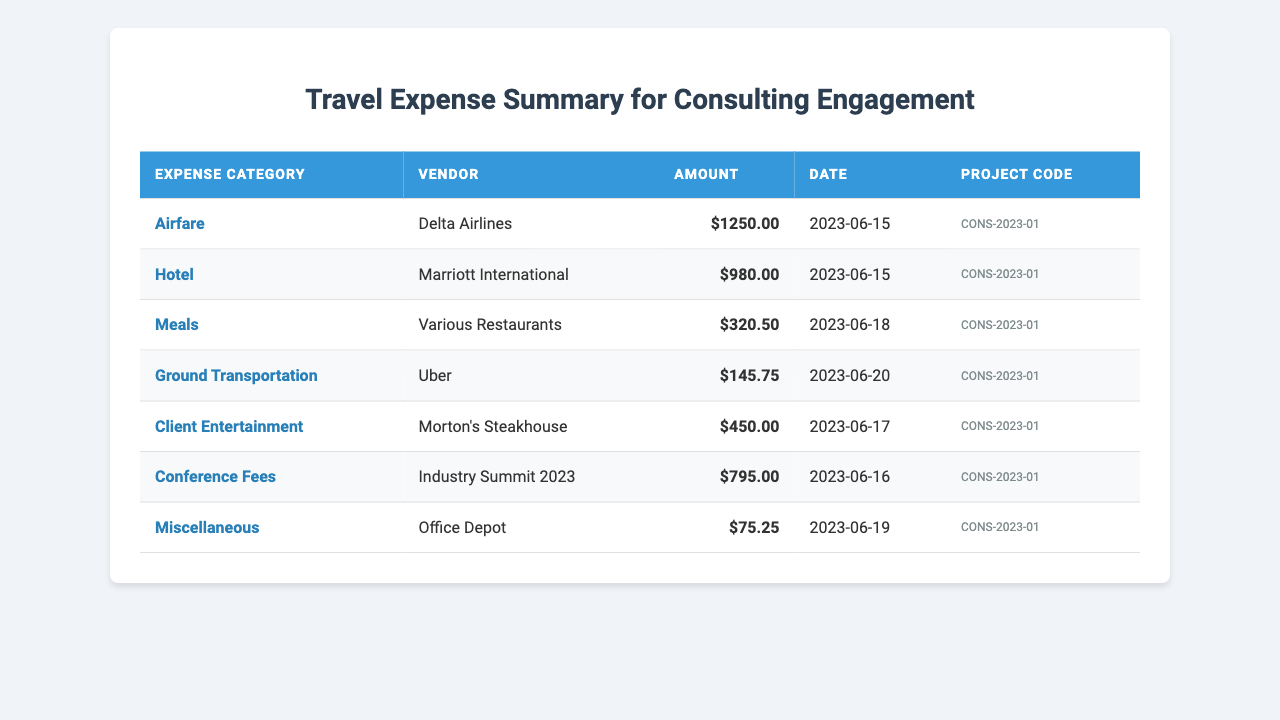What is the total amount spent on Airfare? The amount spent on Airfare is listed as 1250.00 in the table.
Answer: 1250.00 How much was spent on Client Entertainment? The amount spent on Client Entertainment is shown as 450.00 in the table.
Answer: 450.00 Which vendor was used for Hotel expenses? The vendor for Hotel expenses is listed as Marriott International.
Answer: Marriott International What is the total amount spent on all travel expenses? By summing all amounts: 1250.00 + 980.00 + 320.50 + 145.75 + 450.00 + 795.00 + 75.25 = 3016.50.
Answer: 3016.50 What was the date of the Ground Transportation expense? The date for Ground Transportation is noted as 2023-06-20 in the table.
Answer: 2023-06-20 Did any expenses exceed $1000? The expenses for Airfare and Hotel exceed $1000.
Answer: Yes What is the difference between the amount spent on Meals and Ground Transportation? The amount for Meals is 320.50 and for Ground Transportation is 145.75. The difference is 320.50 - 145.75 = 174.75.
Answer: 174.75 What percentage of the total expenses was spent on Conference Fees? The amount spent on Conference Fees is 795.00. The total expenses amount to 3016.50. The percentage is (795.00 / 3016.50) * 100 = 26.35%.
Answer: 26.35% Which expense category had the highest amount spent? The category with the highest amount is Airfare at 1250.00.
Answer: Airfare What was the average cost of the expenses listed? The total amount is 3016.50 with 7 expenses. The average is 3016.50 / 7 ≈ 430.93.
Answer: 430.93 How many different vendors were used for the expenses? The vendors listed are Delta Airlines, Marriott International, Various Restaurants, Uber, Morton's Steakhouse, Industry Summit 2023, and Office Depot. There are 7 different vendors.
Answer: 7 